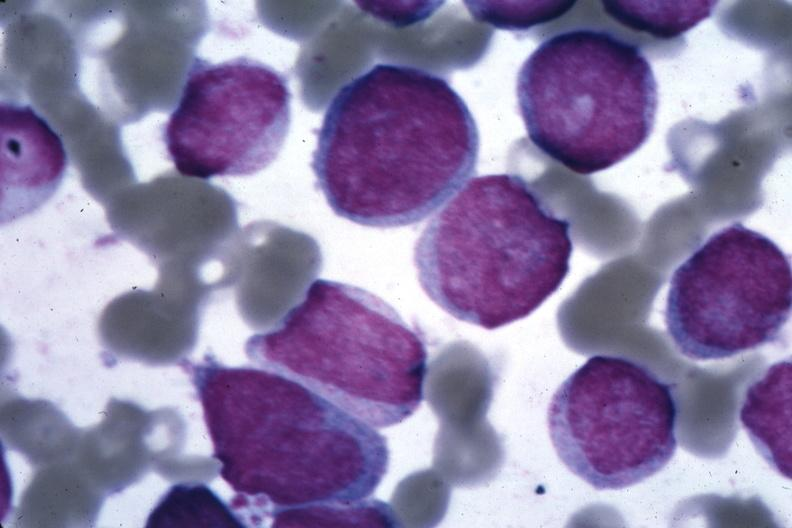s bone marrow present?
Answer the question using a single word or phrase. Yes 